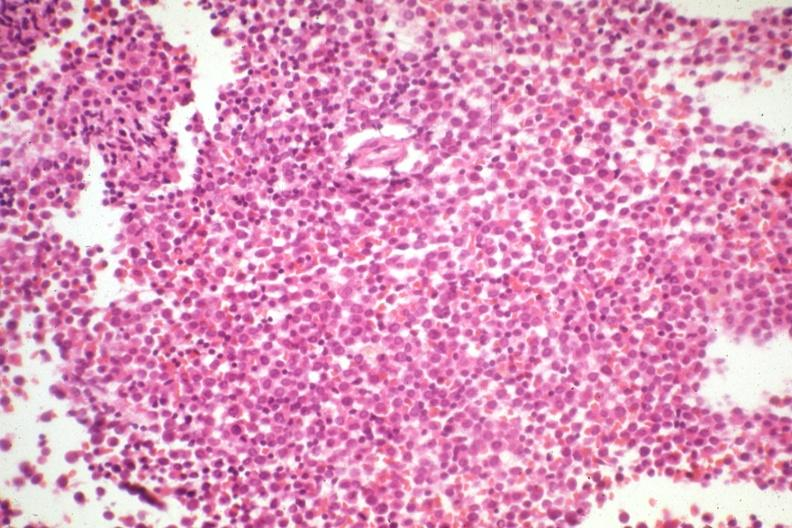what is present?
Answer the question using a single word or phrase. Acute myelogenous leukemia 